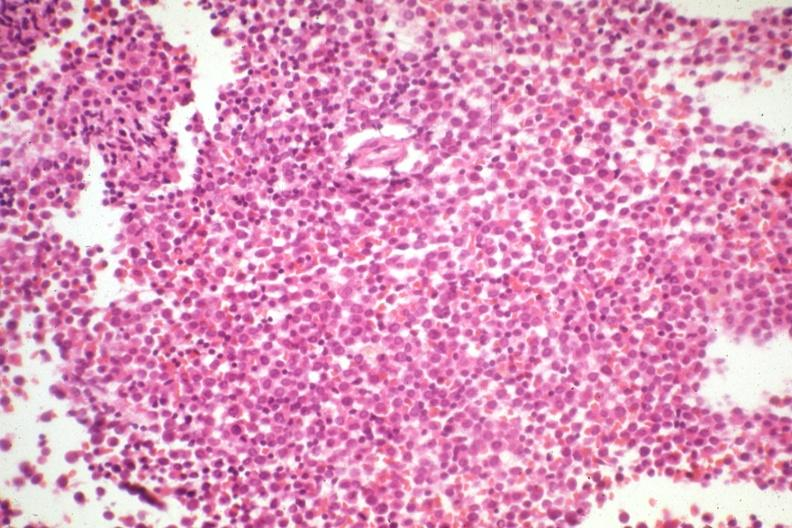what is present?
Answer the question using a single word or phrase. Acute myelogenous leukemia 